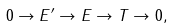Convert formula to latex. <formula><loc_0><loc_0><loc_500><loc_500>0 \rightarrow E ^ { \prime } \rightarrow E \rightarrow T \rightarrow 0 ,</formula> 